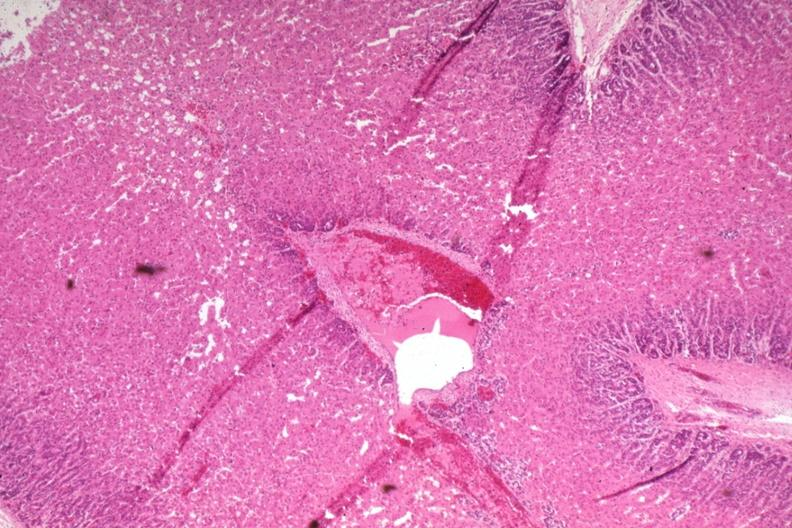what does this image show?
Answer the question using a single word or phrase. Wide fetal zone 2 days old 